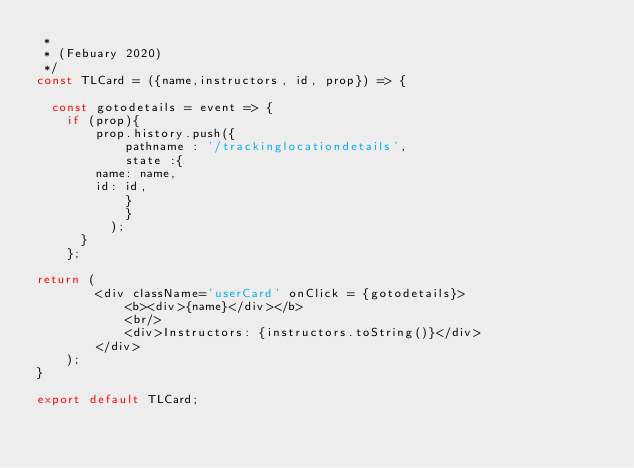<code> <loc_0><loc_0><loc_500><loc_500><_JavaScript_> * 
 * (Febuary 2020)
 */
const TLCard = ({name,instructors, id, prop}) => {

	const gotodetails = event => {
		if (prop){
	    	prop.history.push({
	          pathname : '/trackinglocationdetails',
	          state :{
			  name: name,
			  id: id,
	          }
	          } 
	        );
    	}
  	};

return (
        <div className='userCard' onClick = {gotodetails}>   
            <b><div>{name}</div></b>
            <br/>
            <div>Instructors: {instructors.toString()}</div>
        </div>
    );
}

export default TLCard;</code> 